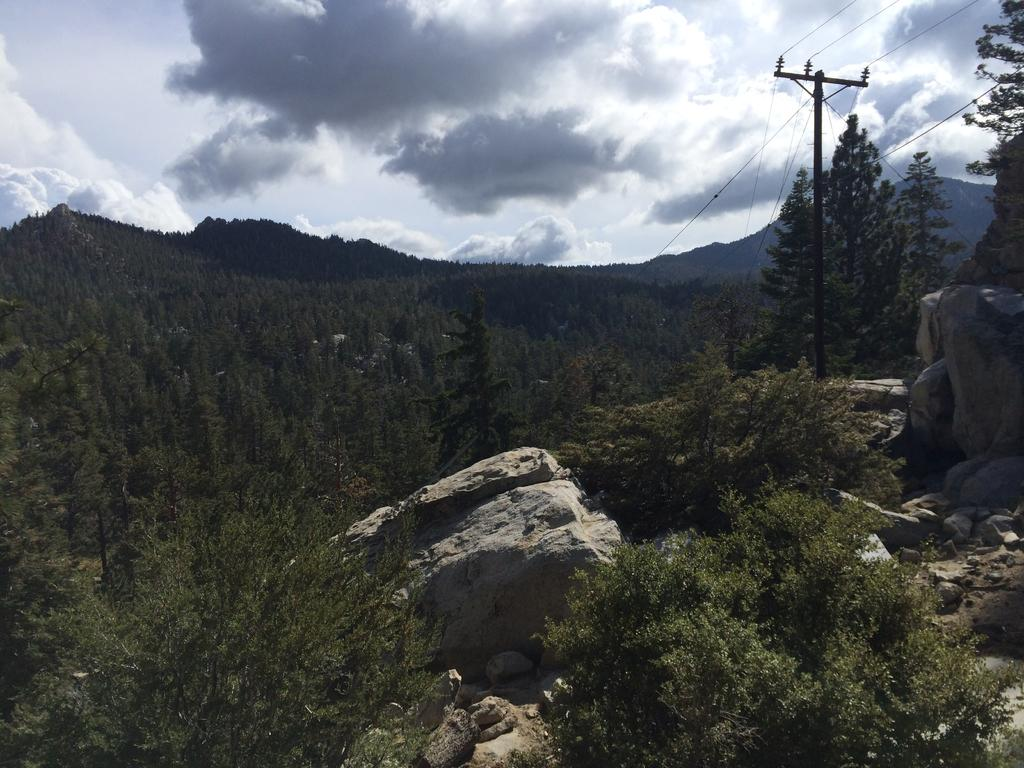What can be seen in the sky in the image? The sky with clouds is visible in the image. What type of vegetation is present in the image? There are trees in the image. What geological features can be seen in the image? Rocks and stones are present in the image. What man-made structures are visible in the image? Electric poles are visible in the image, and electric cables are present. Can you tell me how the goose is exchanging words with the electric pole in the image? There is no goose or any form of communication between a goose and an electric pole in the image. 